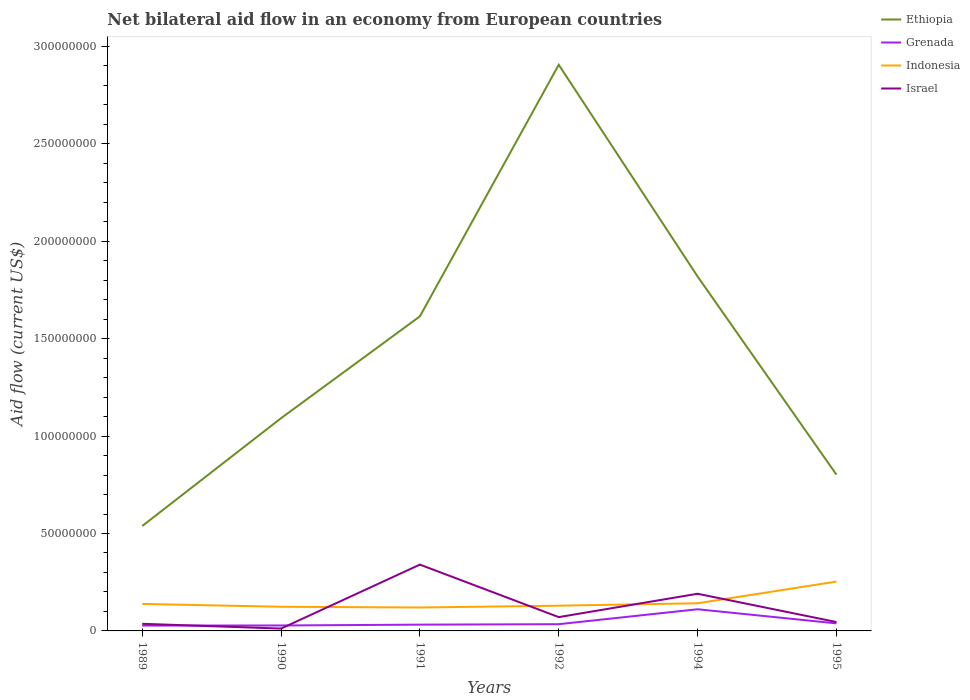Does the line corresponding to Ethiopia intersect with the line corresponding to Grenada?
Provide a short and direct response. No. Across all years, what is the maximum net bilateral aid flow in Ethiopia?
Provide a short and direct response. 5.38e+07. In which year was the net bilateral aid flow in Grenada maximum?
Provide a succinct answer. 1989. What is the total net bilateral aid flow in Israel in the graph?
Your answer should be very brief. -1.79e+07. What is the difference between the highest and the second highest net bilateral aid flow in Israel?
Ensure brevity in your answer.  3.28e+07. What is the difference between the highest and the lowest net bilateral aid flow in Ethiopia?
Offer a very short reply. 3. How many lines are there?
Ensure brevity in your answer.  4. How many years are there in the graph?
Your answer should be very brief. 6. What is the difference between two consecutive major ticks on the Y-axis?
Offer a very short reply. 5.00e+07. Are the values on the major ticks of Y-axis written in scientific E-notation?
Keep it short and to the point. No. Does the graph contain any zero values?
Your answer should be compact. No. Does the graph contain grids?
Ensure brevity in your answer.  No. Where does the legend appear in the graph?
Ensure brevity in your answer.  Top right. What is the title of the graph?
Provide a short and direct response. Net bilateral aid flow in an economy from European countries. What is the label or title of the Y-axis?
Offer a terse response. Aid flow (current US$). What is the Aid flow (current US$) of Ethiopia in 1989?
Your answer should be compact. 5.38e+07. What is the Aid flow (current US$) in Grenada in 1989?
Your answer should be compact. 2.74e+06. What is the Aid flow (current US$) of Indonesia in 1989?
Offer a very short reply. 1.39e+07. What is the Aid flow (current US$) of Israel in 1989?
Provide a succinct answer. 3.66e+06. What is the Aid flow (current US$) of Ethiopia in 1990?
Provide a short and direct response. 1.09e+08. What is the Aid flow (current US$) of Grenada in 1990?
Offer a very short reply. 2.80e+06. What is the Aid flow (current US$) in Indonesia in 1990?
Provide a short and direct response. 1.24e+07. What is the Aid flow (current US$) of Israel in 1990?
Give a very brief answer. 1.20e+06. What is the Aid flow (current US$) in Ethiopia in 1991?
Offer a terse response. 1.61e+08. What is the Aid flow (current US$) of Grenada in 1991?
Give a very brief answer. 3.22e+06. What is the Aid flow (current US$) of Indonesia in 1991?
Offer a terse response. 1.20e+07. What is the Aid flow (current US$) of Israel in 1991?
Provide a succinct answer. 3.40e+07. What is the Aid flow (current US$) in Ethiopia in 1992?
Your answer should be very brief. 2.91e+08. What is the Aid flow (current US$) of Grenada in 1992?
Offer a terse response. 3.46e+06. What is the Aid flow (current US$) in Indonesia in 1992?
Provide a succinct answer. 1.30e+07. What is the Aid flow (current US$) in Israel in 1992?
Provide a succinct answer. 7.09e+06. What is the Aid flow (current US$) of Ethiopia in 1994?
Give a very brief answer. 1.82e+08. What is the Aid flow (current US$) in Grenada in 1994?
Provide a short and direct response. 1.11e+07. What is the Aid flow (current US$) of Indonesia in 1994?
Keep it short and to the point. 1.42e+07. What is the Aid flow (current US$) of Israel in 1994?
Offer a very short reply. 1.91e+07. What is the Aid flow (current US$) in Ethiopia in 1995?
Your answer should be very brief. 8.02e+07. What is the Aid flow (current US$) in Grenada in 1995?
Your response must be concise. 3.87e+06. What is the Aid flow (current US$) of Indonesia in 1995?
Provide a succinct answer. 2.53e+07. What is the Aid flow (current US$) in Israel in 1995?
Give a very brief answer. 4.56e+06. Across all years, what is the maximum Aid flow (current US$) in Ethiopia?
Your answer should be compact. 2.91e+08. Across all years, what is the maximum Aid flow (current US$) of Grenada?
Provide a succinct answer. 1.11e+07. Across all years, what is the maximum Aid flow (current US$) of Indonesia?
Provide a succinct answer. 2.53e+07. Across all years, what is the maximum Aid flow (current US$) in Israel?
Your response must be concise. 3.40e+07. Across all years, what is the minimum Aid flow (current US$) of Ethiopia?
Offer a terse response. 5.38e+07. Across all years, what is the minimum Aid flow (current US$) in Grenada?
Offer a very short reply. 2.74e+06. Across all years, what is the minimum Aid flow (current US$) of Indonesia?
Keep it short and to the point. 1.20e+07. Across all years, what is the minimum Aid flow (current US$) in Israel?
Offer a terse response. 1.20e+06. What is the total Aid flow (current US$) of Ethiopia in the graph?
Provide a short and direct response. 8.77e+08. What is the total Aid flow (current US$) of Grenada in the graph?
Provide a short and direct response. 2.72e+07. What is the total Aid flow (current US$) in Indonesia in the graph?
Provide a short and direct response. 9.08e+07. What is the total Aid flow (current US$) in Israel in the graph?
Your answer should be very brief. 6.96e+07. What is the difference between the Aid flow (current US$) of Ethiopia in 1989 and that in 1990?
Your response must be concise. -5.54e+07. What is the difference between the Aid flow (current US$) of Grenada in 1989 and that in 1990?
Provide a succinct answer. -6.00e+04. What is the difference between the Aid flow (current US$) in Indonesia in 1989 and that in 1990?
Provide a short and direct response. 1.46e+06. What is the difference between the Aid flow (current US$) of Israel in 1989 and that in 1990?
Provide a short and direct response. 2.46e+06. What is the difference between the Aid flow (current US$) in Ethiopia in 1989 and that in 1991?
Keep it short and to the point. -1.08e+08. What is the difference between the Aid flow (current US$) in Grenada in 1989 and that in 1991?
Provide a succinct answer. -4.80e+05. What is the difference between the Aid flow (current US$) of Indonesia in 1989 and that in 1991?
Offer a very short reply. 1.84e+06. What is the difference between the Aid flow (current US$) in Israel in 1989 and that in 1991?
Provide a short and direct response. -3.04e+07. What is the difference between the Aid flow (current US$) in Ethiopia in 1989 and that in 1992?
Your answer should be very brief. -2.37e+08. What is the difference between the Aid flow (current US$) of Grenada in 1989 and that in 1992?
Give a very brief answer. -7.20e+05. What is the difference between the Aid flow (current US$) of Indonesia in 1989 and that in 1992?
Ensure brevity in your answer.  9.10e+05. What is the difference between the Aid flow (current US$) in Israel in 1989 and that in 1992?
Your answer should be compact. -3.43e+06. What is the difference between the Aid flow (current US$) in Ethiopia in 1989 and that in 1994?
Your answer should be compact. -1.28e+08. What is the difference between the Aid flow (current US$) of Grenada in 1989 and that in 1994?
Ensure brevity in your answer.  -8.38e+06. What is the difference between the Aid flow (current US$) in Indonesia in 1989 and that in 1994?
Your response must be concise. -3.40e+05. What is the difference between the Aid flow (current US$) in Israel in 1989 and that in 1994?
Offer a terse response. -1.54e+07. What is the difference between the Aid flow (current US$) in Ethiopia in 1989 and that in 1995?
Provide a succinct answer. -2.64e+07. What is the difference between the Aid flow (current US$) in Grenada in 1989 and that in 1995?
Ensure brevity in your answer.  -1.13e+06. What is the difference between the Aid flow (current US$) in Indonesia in 1989 and that in 1995?
Your response must be concise. -1.15e+07. What is the difference between the Aid flow (current US$) of Israel in 1989 and that in 1995?
Offer a very short reply. -9.00e+05. What is the difference between the Aid flow (current US$) of Ethiopia in 1990 and that in 1991?
Offer a very short reply. -5.23e+07. What is the difference between the Aid flow (current US$) of Grenada in 1990 and that in 1991?
Your answer should be compact. -4.20e+05. What is the difference between the Aid flow (current US$) in Indonesia in 1990 and that in 1991?
Give a very brief answer. 3.80e+05. What is the difference between the Aid flow (current US$) in Israel in 1990 and that in 1991?
Ensure brevity in your answer.  -3.28e+07. What is the difference between the Aid flow (current US$) in Ethiopia in 1990 and that in 1992?
Offer a terse response. -1.81e+08. What is the difference between the Aid flow (current US$) of Grenada in 1990 and that in 1992?
Your response must be concise. -6.60e+05. What is the difference between the Aid flow (current US$) in Indonesia in 1990 and that in 1992?
Your answer should be compact. -5.50e+05. What is the difference between the Aid flow (current US$) in Israel in 1990 and that in 1992?
Your response must be concise. -5.89e+06. What is the difference between the Aid flow (current US$) of Ethiopia in 1990 and that in 1994?
Keep it short and to the point. -7.27e+07. What is the difference between the Aid flow (current US$) in Grenada in 1990 and that in 1994?
Provide a succinct answer. -8.32e+06. What is the difference between the Aid flow (current US$) in Indonesia in 1990 and that in 1994?
Offer a terse response. -1.80e+06. What is the difference between the Aid flow (current US$) in Israel in 1990 and that in 1994?
Provide a short and direct response. -1.79e+07. What is the difference between the Aid flow (current US$) in Ethiopia in 1990 and that in 1995?
Your answer should be compact. 2.90e+07. What is the difference between the Aid flow (current US$) of Grenada in 1990 and that in 1995?
Offer a very short reply. -1.07e+06. What is the difference between the Aid flow (current US$) of Indonesia in 1990 and that in 1995?
Keep it short and to the point. -1.29e+07. What is the difference between the Aid flow (current US$) in Israel in 1990 and that in 1995?
Offer a terse response. -3.36e+06. What is the difference between the Aid flow (current US$) of Ethiopia in 1991 and that in 1992?
Offer a terse response. -1.29e+08. What is the difference between the Aid flow (current US$) of Grenada in 1991 and that in 1992?
Make the answer very short. -2.40e+05. What is the difference between the Aid flow (current US$) of Indonesia in 1991 and that in 1992?
Your answer should be very brief. -9.30e+05. What is the difference between the Aid flow (current US$) in Israel in 1991 and that in 1992?
Make the answer very short. 2.70e+07. What is the difference between the Aid flow (current US$) of Ethiopia in 1991 and that in 1994?
Your answer should be very brief. -2.04e+07. What is the difference between the Aid flow (current US$) in Grenada in 1991 and that in 1994?
Keep it short and to the point. -7.90e+06. What is the difference between the Aid flow (current US$) in Indonesia in 1991 and that in 1994?
Make the answer very short. -2.18e+06. What is the difference between the Aid flow (current US$) of Israel in 1991 and that in 1994?
Your answer should be compact. 1.50e+07. What is the difference between the Aid flow (current US$) in Ethiopia in 1991 and that in 1995?
Your response must be concise. 8.13e+07. What is the difference between the Aid flow (current US$) in Grenada in 1991 and that in 1995?
Keep it short and to the point. -6.50e+05. What is the difference between the Aid flow (current US$) in Indonesia in 1991 and that in 1995?
Your answer should be compact. -1.33e+07. What is the difference between the Aid flow (current US$) in Israel in 1991 and that in 1995?
Offer a terse response. 2.95e+07. What is the difference between the Aid flow (current US$) of Ethiopia in 1992 and that in 1994?
Offer a terse response. 1.09e+08. What is the difference between the Aid flow (current US$) in Grenada in 1992 and that in 1994?
Offer a terse response. -7.66e+06. What is the difference between the Aid flow (current US$) in Indonesia in 1992 and that in 1994?
Your response must be concise. -1.25e+06. What is the difference between the Aid flow (current US$) of Israel in 1992 and that in 1994?
Offer a very short reply. -1.20e+07. What is the difference between the Aid flow (current US$) of Ethiopia in 1992 and that in 1995?
Keep it short and to the point. 2.10e+08. What is the difference between the Aid flow (current US$) of Grenada in 1992 and that in 1995?
Provide a succinct answer. -4.10e+05. What is the difference between the Aid flow (current US$) of Indonesia in 1992 and that in 1995?
Provide a succinct answer. -1.24e+07. What is the difference between the Aid flow (current US$) of Israel in 1992 and that in 1995?
Offer a very short reply. 2.53e+06. What is the difference between the Aid flow (current US$) of Ethiopia in 1994 and that in 1995?
Make the answer very short. 1.02e+08. What is the difference between the Aid flow (current US$) in Grenada in 1994 and that in 1995?
Your response must be concise. 7.25e+06. What is the difference between the Aid flow (current US$) of Indonesia in 1994 and that in 1995?
Your answer should be very brief. -1.11e+07. What is the difference between the Aid flow (current US$) of Israel in 1994 and that in 1995?
Your answer should be compact. 1.45e+07. What is the difference between the Aid flow (current US$) of Ethiopia in 1989 and the Aid flow (current US$) of Grenada in 1990?
Provide a short and direct response. 5.10e+07. What is the difference between the Aid flow (current US$) of Ethiopia in 1989 and the Aid flow (current US$) of Indonesia in 1990?
Your answer should be compact. 4.14e+07. What is the difference between the Aid flow (current US$) of Ethiopia in 1989 and the Aid flow (current US$) of Israel in 1990?
Keep it short and to the point. 5.26e+07. What is the difference between the Aid flow (current US$) in Grenada in 1989 and the Aid flow (current US$) in Indonesia in 1990?
Give a very brief answer. -9.66e+06. What is the difference between the Aid flow (current US$) in Grenada in 1989 and the Aid flow (current US$) in Israel in 1990?
Offer a very short reply. 1.54e+06. What is the difference between the Aid flow (current US$) of Indonesia in 1989 and the Aid flow (current US$) of Israel in 1990?
Keep it short and to the point. 1.27e+07. What is the difference between the Aid flow (current US$) in Ethiopia in 1989 and the Aid flow (current US$) in Grenada in 1991?
Make the answer very short. 5.06e+07. What is the difference between the Aid flow (current US$) of Ethiopia in 1989 and the Aid flow (current US$) of Indonesia in 1991?
Offer a terse response. 4.18e+07. What is the difference between the Aid flow (current US$) in Ethiopia in 1989 and the Aid flow (current US$) in Israel in 1991?
Offer a very short reply. 1.98e+07. What is the difference between the Aid flow (current US$) of Grenada in 1989 and the Aid flow (current US$) of Indonesia in 1991?
Make the answer very short. -9.28e+06. What is the difference between the Aid flow (current US$) of Grenada in 1989 and the Aid flow (current US$) of Israel in 1991?
Your answer should be compact. -3.13e+07. What is the difference between the Aid flow (current US$) of Indonesia in 1989 and the Aid flow (current US$) of Israel in 1991?
Provide a succinct answer. -2.02e+07. What is the difference between the Aid flow (current US$) in Ethiopia in 1989 and the Aid flow (current US$) in Grenada in 1992?
Your response must be concise. 5.04e+07. What is the difference between the Aid flow (current US$) of Ethiopia in 1989 and the Aid flow (current US$) of Indonesia in 1992?
Your response must be concise. 4.09e+07. What is the difference between the Aid flow (current US$) in Ethiopia in 1989 and the Aid flow (current US$) in Israel in 1992?
Offer a terse response. 4.68e+07. What is the difference between the Aid flow (current US$) of Grenada in 1989 and the Aid flow (current US$) of Indonesia in 1992?
Your response must be concise. -1.02e+07. What is the difference between the Aid flow (current US$) in Grenada in 1989 and the Aid flow (current US$) in Israel in 1992?
Offer a very short reply. -4.35e+06. What is the difference between the Aid flow (current US$) in Indonesia in 1989 and the Aid flow (current US$) in Israel in 1992?
Provide a succinct answer. 6.77e+06. What is the difference between the Aid flow (current US$) of Ethiopia in 1989 and the Aid flow (current US$) of Grenada in 1994?
Give a very brief answer. 4.27e+07. What is the difference between the Aid flow (current US$) of Ethiopia in 1989 and the Aid flow (current US$) of Indonesia in 1994?
Provide a succinct answer. 3.96e+07. What is the difference between the Aid flow (current US$) of Ethiopia in 1989 and the Aid flow (current US$) of Israel in 1994?
Your answer should be very brief. 3.48e+07. What is the difference between the Aid flow (current US$) in Grenada in 1989 and the Aid flow (current US$) in Indonesia in 1994?
Your response must be concise. -1.15e+07. What is the difference between the Aid flow (current US$) in Grenada in 1989 and the Aid flow (current US$) in Israel in 1994?
Your answer should be very brief. -1.63e+07. What is the difference between the Aid flow (current US$) in Indonesia in 1989 and the Aid flow (current US$) in Israel in 1994?
Your answer should be compact. -5.22e+06. What is the difference between the Aid flow (current US$) in Ethiopia in 1989 and the Aid flow (current US$) in Grenada in 1995?
Provide a succinct answer. 5.00e+07. What is the difference between the Aid flow (current US$) of Ethiopia in 1989 and the Aid flow (current US$) of Indonesia in 1995?
Your answer should be compact. 2.85e+07. What is the difference between the Aid flow (current US$) in Ethiopia in 1989 and the Aid flow (current US$) in Israel in 1995?
Provide a succinct answer. 4.93e+07. What is the difference between the Aid flow (current US$) in Grenada in 1989 and the Aid flow (current US$) in Indonesia in 1995?
Provide a short and direct response. -2.26e+07. What is the difference between the Aid flow (current US$) of Grenada in 1989 and the Aid flow (current US$) of Israel in 1995?
Offer a very short reply. -1.82e+06. What is the difference between the Aid flow (current US$) of Indonesia in 1989 and the Aid flow (current US$) of Israel in 1995?
Offer a terse response. 9.30e+06. What is the difference between the Aid flow (current US$) of Ethiopia in 1990 and the Aid flow (current US$) of Grenada in 1991?
Provide a short and direct response. 1.06e+08. What is the difference between the Aid flow (current US$) of Ethiopia in 1990 and the Aid flow (current US$) of Indonesia in 1991?
Offer a very short reply. 9.72e+07. What is the difference between the Aid flow (current US$) of Ethiopia in 1990 and the Aid flow (current US$) of Israel in 1991?
Ensure brevity in your answer.  7.52e+07. What is the difference between the Aid flow (current US$) of Grenada in 1990 and the Aid flow (current US$) of Indonesia in 1991?
Provide a short and direct response. -9.22e+06. What is the difference between the Aid flow (current US$) in Grenada in 1990 and the Aid flow (current US$) in Israel in 1991?
Offer a very short reply. -3.12e+07. What is the difference between the Aid flow (current US$) in Indonesia in 1990 and the Aid flow (current US$) in Israel in 1991?
Make the answer very short. -2.16e+07. What is the difference between the Aid flow (current US$) of Ethiopia in 1990 and the Aid flow (current US$) of Grenada in 1992?
Your answer should be very brief. 1.06e+08. What is the difference between the Aid flow (current US$) in Ethiopia in 1990 and the Aid flow (current US$) in Indonesia in 1992?
Your answer should be very brief. 9.62e+07. What is the difference between the Aid flow (current US$) in Ethiopia in 1990 and the Aid flow (current US$) in Israel in 1992?
Keep it short and to the point. 1.02e+08. What is the difference between the Aid flow (current US$) of Grenada in 1990 and the Aid flow (current US$) of Indonesia in 1992?
Keep it short and to the point. -1.02e+07. What is the difference between the Aid flow (current US$) in Grenada in 1990 and the Aid flow (current US$) in Israel in 1992?
Make the answer very short. -4.29e+06. What is the difference between the Aid flow (current US$) of Indonesia in 1990 and the Aid flow (current US$) of Israel in 1992?
Your response must be concise. 5.31e+06. What is the difference between the Aid flow (current US$) in Ethiopia in 1990 and the Aid flow (current US$) in Grenada in 1994?
Offer a terse response. 9.81e+07. What is the difference between the Aid flow (current US$) of Ethiopia in 1990 and the Aid flow (current US$) of Indonesia in 1994?
Make the answer very short. 9.50e+07. What is the difference between the Aid flow (current US$) of Ethiopia in 1990 and the Aid flow (current US$) of Israel in 1994?
Offer a very short reply. 9.01e+07. What is the difference between the Aid flow (current US$) in Grenada in 1990 and the Aid flow (current US$) in Indonesia in 1994?
Provide a short and direct response. -1.14e+07. What is the difference between the Aid flow (current US$) in Grenada in 1990 and the Aid flow (current US$) in Israel in 1994?
Provide a short and direct response. -1.63e+07. What is the difference between the Aid flow (current US$) in Indonesia in 1990 and the Aid flow (current US$) in Israel in 1994?
Provide a succinct answer. -6.68e+06. What is the difference between the Aid flow (current US$) in Ethiopia in 1990 and the Aid flow (current US$) in Grenada in 1995?
Ensure brevity in your answer.  1.05e+08. What is the difference between the Aid flow (current US$) of Ethiopia in 1990 and the Aid flow (current US$) of Indonesia in 1995?
Make the answer very short. 8.39e+07. What is the difference between the Aid flow (current US$) of Ethiopia in 1990 and the Aid flow (current US$) of Israel in 1995?
Your answer should be very brief. 1.05e+08. What is the difference between the Aid flow (current US$) of Grenada in 1990 and the Aid flow (current US$) of Indonesia in 1995?
Make the answer very short. -2.25e+07. What is the difference between the Aid flow (current US$) of Grenada in 1990 and the Aid flow (current US$) of Israel in 1995?
Provide a short and direct response. -1.76e+06. What is the difference between the Aid flow (current US$) of Indonesia in 1990 and the Aid flow (current US$) of Israel in 1995?
Keep it short and to the point. 7.84e+06. What is the difference between the Aid flow (current US$) of Ethiopia in 1991 and the Aid flow (current US$) of Grenada in 1992?
Your answer should be compact. 1.58e+08. What is the difference between the Aid flow (current US$) of Ethiopia in 1991 and the Aid flow (current US$) of Indonesia in 1992?
Offer a very short reply. 1.49e+08. What is the difference between the Aid flow (current US$) of Ethiopia in 1991 and the Aid flow (current US$) of Israel in 1992?
Your answer should be compact. 1.54e+08. What is the difference between the Aid flow (current US$) in Grenada in 1991 and the Aid flow (current US$) in Indonesia in 1992?
Your response must be concise. -9.73e+06. What is the difference between the Aid flow (current US$) in Grenada in 1991 and the Aid flow (current US$) in Israel in 1992?
Make the answer very short. -3.87e+06. What is the difference between the Aid flow (current US$) of Indonesia in 1991 and the Aid flow (current US$) of Israel in 1992?
Ensure brevity in your answer.  4.93e+06. What is the difference between the Aid flow (current US$) of Ethiopia in 1991 and the Aid flow (current US$) of Grenada in 1994?
Make the answer very short. 1.50e+08. What is the difference between the Aid flow (current US$) of Ethiopia in 1991 and the Aid flow (current US$) of Indonesia in 1994?
Make the answer very short. 1.47e+08. What is the difference between the Aid flow (current US$) in Ethiopia in 1991 and the Aid flow (current US$) in Israel in 1994?
Provide a succinct answer. 1.42e+08. What is the difference between the Aid flow (current US$) of Grenada in 1991 and the Aid flow (current US$) of Indonesia in 1994?
Offer a very short reply. -1.10e+07. What is the difference between the Aid flow (current US$) in Grenada in 1991 and the Aid flow (current US$) in Israel in 1994?
Your answer should be very brief. -1.59e+07. What is the difference between the Aid flow (current US$) of Indonesia in 1991 and the Aid flow (current US$) of Israel in 1994?
Provide a short and direct response. -7.06e+06. What is the difference between the Aid flow (current US$) in Ethiopia in 1991 and the Aid flow (current US$) in Grenada in 1995?
Provide a short and direct response. 1.58e+08. What is the difference between the Aid flow (current US$) of Ethiopia in 1991 and the Aid flow (current US$) of Indonesia in 1995?
Keep it short and to the point. 1.36e+08. What is the difference between the Aid flow (current US$) of Ethiopia in 1991 and the Aid flow (current US$) of Israel in 1995?
Keep it short and to the point. 1.57e+08. What is the difference between the Aid flow (current US$) of Grenada in 1991 and the Aid flow (current US$) of Indonesia in 1995?
Offer a terse response. -2.21e+07. What is the difference between the Aid flow (current US$) of Grenada in 1991 and the Aid flow (current US$) of Israel in 1995?
Provide a succinct answer. -1.34e+06. What is the difference between the Aid flow (current US$) of Indonesia in 1991 and the Aid flow (current US$) of Israel in 1995?
Your response must be concise. 7.46e+06. What is the difference between the Aid flow (current US$) of Ethiopia in 1992 and the Aid flow (current US$) of Grenada in 1994?
Offer a terse response. 2.80e+08. What is the difference between the Aid flow (current US$) of Ethiopia in 1992 and the Aid flow (current US$) of Indonesia in 1994?
Provide a short and direct response. 2.76e+08. What is the difference between the Aid flow (current US$) of Ethiopia in 1992 and the Aid flow (current US$) of Israel in 1994?
Your response must be concise. 2.72e+08. What is the difference between the Aid flow (current US$) of Grenada in 1992 and the Aid flow (current US$) of Indonesia in 1994?
Give a very brief answer. -1.07e+07. What is the difference between the Aid flow (current US$) in Grenada in 1992 and the Aid flow (current US$) in Israel in 1994?
Offer a very short reply. -1.56e+07. What is the difference between the Aid flow (current US$) of Indonesia in 1992 and the Aid flow (current US$) of Israel in 1994?
Provide a short and direct response. -6.13e+06. What is the difference between the Aid flow (current US$) in Ethiopia in 1992 and the Aid flow (current US$) in Grenada in 1995?
Keep it short and to the point. 2.87e+08. What is the difference between the Aid flow (current US$) in Ethiopia in 1992 and the Aid flow (current US$) in Indonesia in 1995?
Make the answer very short. 2.65e+08. What is the difference between the Aid flow (current US$) of Ethiopia in 1992 and the Aid flow (current US$) of Israel in 1995?
Offer a very short reply. 2.86e+08. What is the difference between the Aid flow (current US$) in Grenada in 1992 and the Aid flow (current US$) in Indonesia in 1995?
Your answer should be very brief. -2.19e+07. What is the difference between the Aid flow (current US$) in Grenada in 1992 and the Aid flow (current US$) in Israel in 1995?
Provide a succinct answer. -1.10e+06. What is the difference between the Aid flow (current US$) in Indonesia in 1992 and the Aid flow (current US$) in Israel in 1995?
Offer a terse response. 8.39e+06. What is the difference between the Aid flow (current US$) in Ethiopia in 1994 and the Aid flow (current US$) in Grenada in 1995?
Give a very brief answer. 1.78e+08. What is the difference between the Aid flow (current US$) of Ethiopia in 1994 and the Aid flow (current US$) of Indonesia in 1995?
Make the answer very short. 1.57e+08. What is the difference between the Aid flow (current US$) in Ethiopia in 1994 and the Aid flow (current US$) in Israel in 1995?
Your response must be concise. 1.77e+08. What is the difference between the Aid flow (current US$) in Grenada in 1994 and the Aid flow (current US$) in Indonesia in 1995?
Offer a very short reply. -1.42e+07. What is the difference between the Aid flow (current US$) of Grenada in 1994 and the Aid flow (current US$) of Israel in 1995?
Your answer should be compact. 6.56e+06. What is the difference between the Aid flow (current US$) in Indonesia in 1994 and the Aid flow (current US$) in Israel in 1995?
Provide a short and direct response. 9.64e+06. What is the average Aid flow (current US$) of Ethiopia per year?
Ensure brevity in your answer.  1.46e+08. What is the average Aid flow (current US$) of Grenada per year?
Provide a short and direct response. 4.54e+06. What is the average Aid flow (current US$) of Indonesia per year?
Make the answer very short. 1.51e+07. What is the average Aid flow (current US$) of Israel per year?
Keep it short and to the point. 1.16e+07. In the year 1989, what is the difference between the Aid flow (current US$) of Ethiopia and Aid flow (current US$) of Grenada?
Your response must be concise. 5.11e+07. In the year 1989, what is the difference between the Aid flow (current US$) of Ethiopia and Aid flow (current US$) of Indonesia?
Provide a short and direct response. 4.00e+07. In the year 1989, what is the difference between the Aid flow (current US$) in Ethiopia and Aid flow (current US$) in Israel?
Give a very brief answer. 5.02e+07. In the year 1989, what is the difference between the Aid flow (current US$) in Grenada and Aid flow (current US$) in Indonesia?
Give a very brief answer. -1.11e+07. In the year 1989, what is the difference between the Aid flow (current US$) of Grenada and Aid flow (current US$) of Israel?
Your response must be concise. -9.20e+05. In the year 1989, what is the difference between the Aid flow (current US$) of Indonesia and Aid flow (current US$) of Israel?
Offer a very short reply. 1.02e+07. In the year 1990, what is the difference between the Aid flow (current US$) of Ethiopia and Aid flow (current US$) of Grenada?
Provide a short and direct response. 1.06e+08. In the year 1990, what is the difference between the Aid flow (current US$) in Ethiopia and Aid flow (current US$) in Indonesia?
Offer a terse response. 9.68e+07. In the year 1990, what is the difference between the Aid flow (current US$) of Ethiopia and Aid flow (current US$) of Israel?
Ensure brevity in your answer.  1.08e+08. In the year 1990, what is the difference between the Aid flow (current US$) of Grenada and Aid flow (current US$) of Indonesia?
Provide a short and direct response. -9.60e+06. In the year 1990, what is the difference between the Aid flow (current US$) of Grenada and Aid flow (current US$) of Israel?
Give a very brief answer. 1.60e+06. In the year 1990, what is the difference between the Aid flow (current US$) in Indonesia and Aid flow (current US$) in Israel?
Your answer should be very brief. 1.12e+07. In the year 1991, what is the difference between the Aid flow (current US$) of Ethiopia and Aid flow (current US$) of Grenada?
Your answer should be very brief. 1.58e+08. In the year 1991, what is the difference between the Aid flow (current US$) in Ethiopia and Aid flow (current US$) in Indonesia?
Your answer should be very brief. 1.49e+08. In the year 1991, what is the difference between the Aid flow (current US$) of Ethiopia and Aid flow (current US$) of Israel?
Your answer should be very brief. 1.27e+08. In the year 1991, what is the difference between the Aid flow (current US$) in Grenada and Aid flow (current US$) in Indonesia?
Provide a short and direct response. -8.80e+06. In the year 1991, what is the difference between the Aid flow (current US$) in Grenada and Aid flow (current US$) in Israel?
Offer a terse response. -3.08e+07. In the year 1991, what is the difference between the Aid flow (current US$) of Indonesia and Aid flow (current US$) of Israel?
Your response must be concise. -2.20e+07. In the year 1992, what is the difference between the Aid flow (current US$) in Ethiopia and Aid flow (current US$) in Grenada?
Provide a succinct answer. 2.87e+08. In the year 1992, what is the difference between the Aid flow (current US$) in Ethiopia and Aid flow (current US$) in Indonesia?
Your answer should be compact. 2.78e+08. In the year 1992, what is the difference between the Aid flow (current US$) of Ethiopia and Aid flow (current US$) of Israel?
Give a very brief answer. 2.84e+08. In the year 1992, what is the difference between the Aid flow (current US$) of Grenada and Aid flow (current US$) of Indonesia?
Give a very brief answer. -9.49e+06. In the year 1992, what is the difference between the Aid flow (current US$) in Grenada and Aid flow (current US$) in Israel?
Provide a succinct answer. -3.63e+06. In the year 1992, what is the difference between the Aid flow (current US$) in Indonesia and Aid flow (current US$) in Israel?
Give a very brief answer. 5.86e+06. In the year 1994, what is the difference between the Aid flow (current US$) in Ethiopia and Aid flow (current US$) in Grenada?
Provide a short and direct response. 1.71e+08. In the year 1994, what is the difference between the Aid flow (current US$) in Ethiopia and Aid flow (current US$) in Indonesia?
Provide a succinct answer. 1.68e+08. In the year 1994, what is the difference between the Aid flow (current US$) of Ethiopia and Aid flow (current US$) of Israel?
Your response must be concise. 1.63e+08. In the year 1994, what is the difference between the Aid flow (current US$) in Grenada and Aid flow (current US$) in Indonesia?
Your response must be concise. -3.08e+06. In the year 1994, what is the difference between the Aid flow (current US$) of Grenada and Aid flow (current US$) of Israel?
Your answer should be very brief. -7.96e+06. In the year 1994, what is the difference between the Aid flow (current US$) in Indonesia and Aid flow (current US$) in Israel?
Your answer should be compact. -4.88e+06. In the year 1995, what is the difference between the Aid flow (current US$) of Ethiopia and Aid flow (current US$) of Grenada?
Give a very brief answer. 7.63e+07. In the year 1995, what is the difference between the Aid flow (current US$) in Ethiopia and Aid flow (current US$) in Indonesia?
Your answer should be compact. 5.49e+07. In the year 1995, what is the difference between the Aid flow (current US$) of Ethiopia and Aid flow (current US$) of Israel?
Your response must be concise. 7.56e+07. In the year 1995, what is the difference between the Aid flow (current US$) of Grenada and Aid flow (current US$) of Indonesia?
Provide a succinct answer. -2.15e+07. In the year 1995, what is the difference between the Aid flow (current US$) of Grenada and Aid flow (current US$) of Israel?
Keep it short and to the point. -6.90e+05. In the year 1995, what is the difference between the Aid flow (current US$) of Indonesia and Aid flow (current US$) of Israel?
Give a very brief answer. 2.08e+07. What is the ratio of the Aid flow (current US$) in Ethiopia in 1989 to that in 1990?
Make the answer very short. 0.49. What is the ratio of the Aid flow (current US$) in Grenada in 1989 to that in 1990?
Ensure brevity in your answer.  0.98. What is the ratio of the Aid flow (current US$) of Indonesia in 1989 to that in 1990?
Your response must be concise. 1.12. What is the ratio of the Aid flow (current US$) in Israel in 1989 to that in 1990?
Keep it short and to the point. 3.05. What is the ratio of the Aid flow (current US$) of Ethiopia in 1989 to that in 1991?
Ensure brevity in your answer.  0.33. What is the ratio of the Aid flow (current US$) in Grenada in 1989 to that in 1991?
Your response must be concise. 0.85. What is the ratio of the Aid flow (current US$) in Indonesia in 1989 to that in 1991?
Ensure brevity in your answer.  1.15. What is the ratio of the Aid flow (current US$) in Israel in 1989 to that in 1991?
Give a very brief answer. 0.11. What is the ratio of the Aid flow (current US$) of Ethiopia in 1989 to that in 1992?
Ensure brevity in your answer.  0.19. What is the ratio of the Aid flow (current US$) in Grenada in 1989 to that in 1992?
Keep it short and to the point. 0.79. What is the ratio of the Aid flow (current US$) of Indonesia in 1989 to that in 1992?
Make the answer very short. 1.07. What is the ratio of the Aid flow (current US$) in Israel in 1989 to that in 1992?
Provide a succinct answer. 0.52. What is the ratio of the Aid flow (current US$) of Ethiopia in 1989 to that in 1994?
Make the answer very short. 0.3. What is the ratio of the Aid flow (current US$) of Grenada in 1989 to that in 1994?
Your answer should be very brief. 0.25. What is the ratio of the Aid flow (current US$) in Indonesia in 1989 to that in 1994?
Ensure brevity in your answer.  0.98. What is the ratio of the Aid flow (current US$) of Israel in 1989 to that in 1994?
Give a very brief answer. 0.19. What is the ratio of the Aid flow (current US$) of Ethiopia in 1989 to that in 1995?
Your answer should be compact. 0.67. What is the ratio of the Aid flow (current US$) of Grenada in 1989 to that in 1995?
Offer a terse response. 0.71. What is the ratio of the Aid flow (current US$) of Indonesia in 1989 to that in 1995?
Offer a terse response. 0.55. What is the ratio of the Aid flow (current US$) of Israel in 1989 to that in 1995?
Your answer should be very brief. 0.8. What is the ratio of the Aid flow (current US$) in Ethiopia in 1990 to that in 1991?
Your response must be concise. 0.68. What is the ratio of the Aid flow (current US$) of Grenada in 1990 to that in 1991?
Your response must be concise. 0.87. What is the ratio of the Aid flow (current US$) in Indonesia in 1990 to that in 1991?
Your answer should be very brief. 1.03. What is the ratio of the Aid flow (current US$) of Israel in 1990 to that in 1991?
Your answer should be compact. 0.04. What is the ratio of the Aid flow (current US$) of Ethiopia in 1990 to that in 1992?
Provide a short and direct response. 0.38. What is the ratio of the Aid flow (current US$) in Grenada in 1990 to that in 1992?
Your response must be concise. 0.81. What is the ratio of the Aid flow (current US$) of Indonesia in 1990 to that in 1992?
Provide a short and direct response. 0.96. What is the ratio of the Aid flow (current US$) of Israel in 1990 to that in 1992?
Keep it short and to the point. 0.17. What is the ratio of the Aid flow (current US$) in Ethiopia in 1990 to that in 1994?
Your answer should be very brief. 0.6. What is the ratio of the Aid flow (current US$) in Grenada in 1990 to that in 1994?
Offer a very short reply. 0.25. What is the ratio of the Aid flow (current US$) in Indonesia in 1990 to that in 1994?
Provide a succinct answer. 0.87. What is the ratio of the Aid flow (current US$) in Israel in 1990 to that in 1994?
Your answer should be compact. 0.06. What is the ratio of the Aid flow (current US$) of Ethiopia in 1990 to that in 1995?
Keep it short and to the point. 1.36. What is the ratio of the Aid flow (current US$) in Grenada in 1990 to that in 1995?
Ensure brevity in your answer.  0.72. What is the ratio of the Aid flow (current US$) in Indonesia in 1990 to that in 1995?
Offer a very short reply. 0.49. What is the ratio of the Aid flow (current US$) of Israel in 1990 to that in 1995?
Provide a short and direct response. 0.26. What is the ratio of the Aid flow (current US$) in Ethiopia in 1991 to that in 1992?
Ensure brevity in your answer.  0.56. What is the ratio of the Aid flow (current US$) of Grenada in 1991 to that in 1992?
Your answer should be very brief. 0.93. What is the ratio of the Aid flow (current US$) of Indonesia in 1991 to that in 1992?
Offer a terse response. 0.93. What is the ratio of the Aid flow (current US$) of Israel in 1991 to that in 1992?
Keep it short and to the point. 4.8. What is the ratio of the Aid flow (current US$) of Ethiopia in 1991 to that in 1994?
Provide a succinct answer. 0.89. What is the ratio of the Aid flow (current US$) in Grenada in 1991 to that in 1994?
Offer a terse response. 0.29. What is the ratio of the Aid flow (current US$) in Indonesia in 1991 to that in 1994?
Give a very brief answer. 0.85. What is the ratio of the Aid flow (current US$) in Israel in 1991 to that in 1994?
Provide a short and direct response. 1.78. What is the ratio of the Aid flow (current US$) of Ethiopia in 1991 to that in 1995?
Make the answer very short. 2.01. What is the ratio of the Aid flow (current US$) in Grenada in 1991 to that in 1995?
Offer a terse response. 0.83. What is the ratio of the Aid flow (current US$) of Indonesia in 1991 to that in 1995?
Provide a short and direct response. 0.47. What is the ratio of the Aid flow (current US$) in Israel in 1991 to that in 1995?
Ensure brevity in your answer.  7.46. What is the ratio of the Aid flow (current US$) of Ethiopia in 1992 to that in 1994?
Offer a terse response. 1.6. What is the ratio of the Aid flow (current US$) of Grenada in 1992 to that in 1994?
Your response must be concise. 0.31. What is the ratio of the Aid flow (current US$) of Indonesia in 1992 to that in 1994?
Your answer should be compact. 0.91. What is the ratio of the Aid flow (current US$) of Israel in 1992 to that in 1994?
Provide a short and direct response. 0.37. What is the ratio of the Aid flow (current US$) in Ethiopia in 1992 to that in 1995?
Your answer should be very brief. 3.62. What is the ratio of the Aid flow (current US$) in Grenada in 1992 to that in 1995?
Keep it short and to the point. 0.89. What is the ratio of the Aid flow (current US$) of Indonesia in 1992 to that in 1995?
Provide a short and direct response. 0.51. What is the ratio of the Aid flow (current US$) in Israel in 1992 to that in 1995?
Offer a very short reply. 1.55. What is the ratio of the Aid flow (current US$) in Ethiopia in 1994 to that in 1995?
Offer a very short reply. 2.27. What is the ratio of the Aid flow (current US$) of Grenada in 1994 to that in 1995?
Keep it short and to the point. 2.87. What is the ratio of the Aid flow (current US$) of Indonesia in 1994 to that in 1995?
Provide a short and direct response. 0.56. What is the ratio of the Aid flow (current US$) of Israel in 1994 to that in 1995?
Your answer should be compact. 4.18. What is the difference between the highest and the second highest Aid flow (current US$) in Ethiopia?
Ensure brevity in your answer.  1.09e+08. What is the difference between the highest and the second highest Aid flow (current US$) of Grenada?
Offer a very short reply. 7.25e+06. What is the difference between the highest and the second highest Aid flow (current US$) of Indonesia?
Give a very brief answer. 1.11e+07. What is the difference between the highest and the second highest Aid flow (current US$) in Israel?
Give a very brief answer. 1.50e+07. What is the difference between the highest and the lowest Aid flow (current US$) of Ethiopia?
Ensure brevity in your answer.  2.37e+08. What is the difference between the highest and the lowest Aid flow (current US$) of Grenada?
Your answer should be compact. 8.38e+06. What is the difference between the highest and the lowest Aid flow (current US$) of Indonesia?
Keep it short and to the point. 1.33e+07. What is the difference between the highest and the lowest Aid flow (current US$) in Israel?
Offer a terse response. 3.28e+07. 